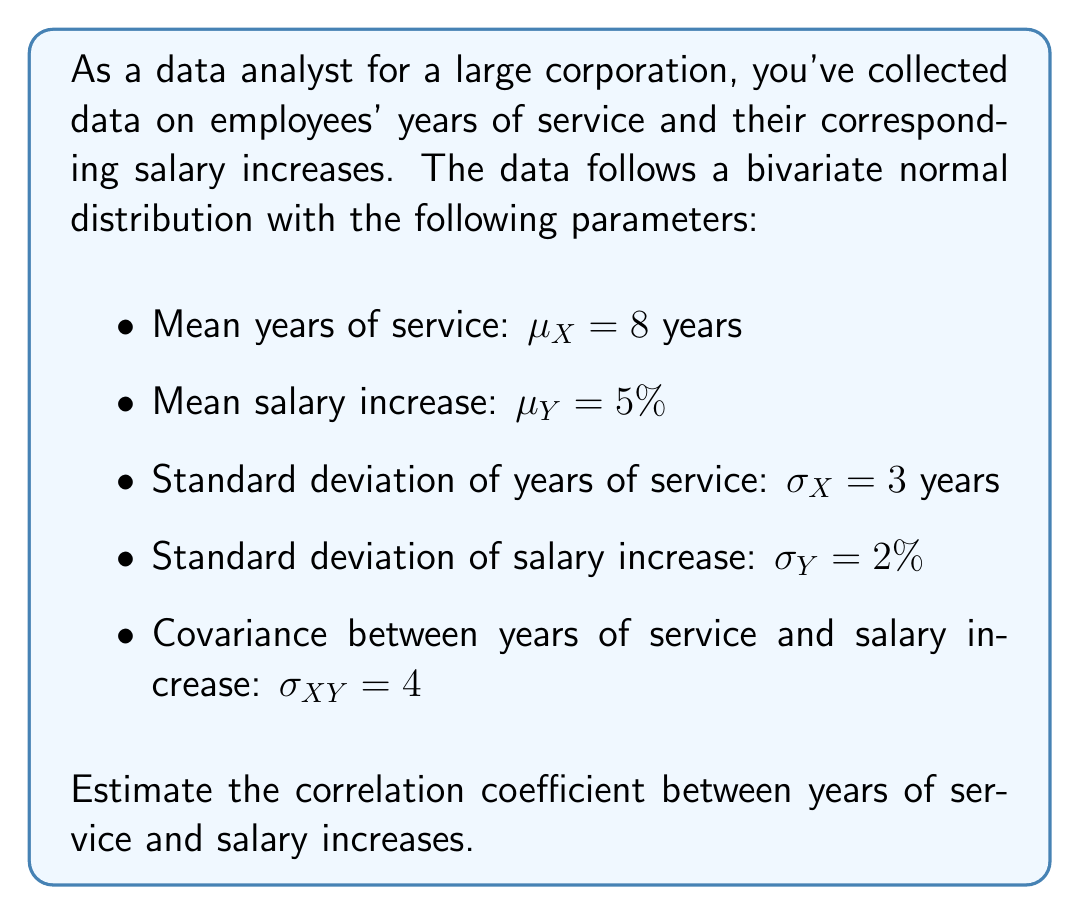Provide a solution to this math problem. To estimate the correlation coefficient between years of service and salary increases, we'll use the formula for the correlation coefficient in a bivariate normal distribution:

$$\rho_{XY} = \frac{\sigma_{XY}}{\sigma_X \sigma_Y}$$

Where:
$\rho_{XY}$ is the correlation coefficient
$\sigma_{XY}$ is the covariance between X and Y
$\sigma_X$ is the standard deviation of X
$\sigma_Y$ is the standard deviation of Y

We're given:
$\sigma_{XY} = 4$
$\sigma_X = 3$ years
$\sigma_Y = 2\%$

Let's substitute these values into the formula:

$$\rho_{XY} = \frac{4}{3 \cdot 2}$$

$$\rho_{XY} = \frac{4}{6}$$

$$\rho_{XY} = \frac{2}{3} \approx 0.6667$$

The correlation coefficient is always between -1 and 1. A value of 0.6667 indicates a moderately strong positive correlation between years of service and salary increases.
Answer: $\rho_{XY} = \frac{2}{3} \approx 0.6667$ 